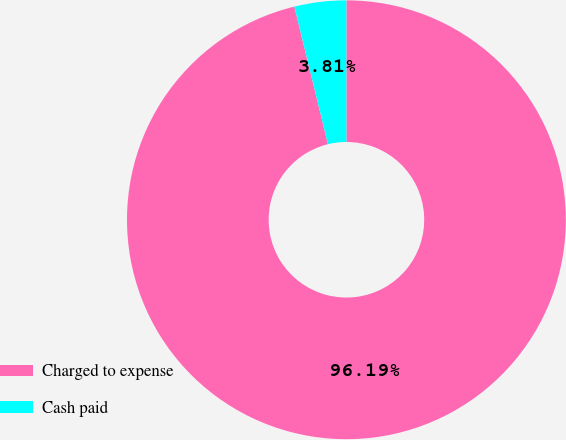Convert chart to OTSL. <chart><loc_0><loc_0><loc_500><loc_500><pie_chart><fcel>Charged to expense<fcel>Cash paid<nl><fcel>96.19%<fcel>3.81%<nl></chart> 